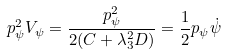<formula> <loc_0><loc_0><loc_500><loc_500>p _ { \psi } ^ { 2 } V _ { \psi } = \frac { p _ { \psi } ^ { 2 } } { 2 ( C + \lambda _ { 3 } ^ { 2 } D ) } = \frac { 1 } { 2 } p _ { \psi } \dot { \psi }</formula> 